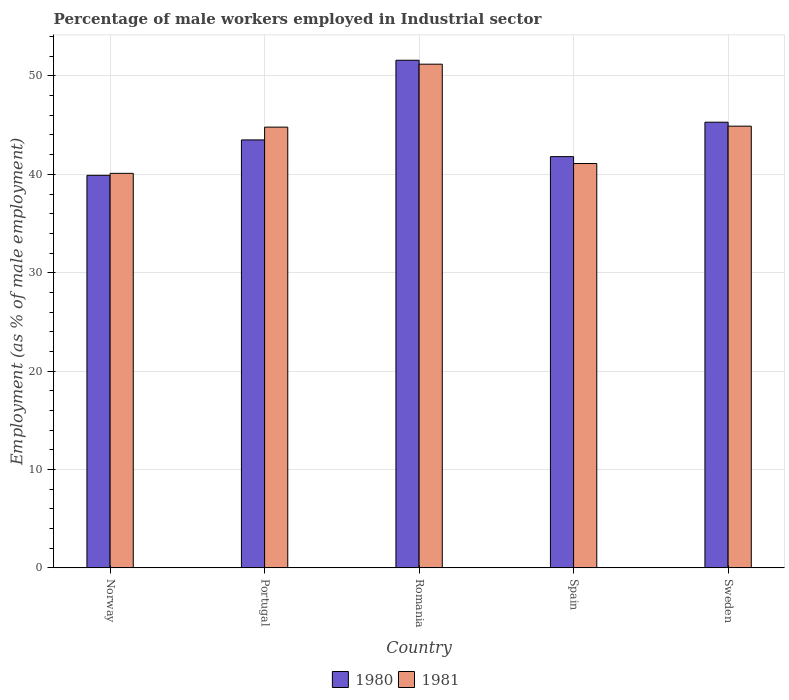How many different coloured bars are there?
Provide a succinct answer. 2. How many groups of bars are there?
Make the answer very short. 5. Are the number of bars on each tick of the X-axis equal?
Your answer should be compact. Yes. How many bars are there on the 2nd tick from the left?
Provide a short and direct response. 2. How many bars are there on the 3rd tick from the right?
Offer a very short reply. 2. What is the label of the 3rd group of bars from the left?
Provide a short and direct response. Romania. What is the percentage of male workers employed in Industrial sector in 1981 in Sweden?
Your response must be concise. 44.9. Across all countries, what is the maximum percentage of male workers employed in Industrial sector in 1980?
Make the answer very short. 51.6. Across all countries, what is the minimum percentage of male workers employed in Industrial sector in 1980?
Keep it short and to the point. 39.9. In which country was the percentage of male workers employed in Industrial sector in 1981 maximum?
Provide a succinct answer. Romania. What is the total percentage of male workers employed in Industrial sector in 1980 in the graph?
Give a very brief answer. 222.1. What is the difference between the percentage of male workers employed in Industrial sector in 1980 in Norway and that in Portugal?
Your answer should be very brief. -3.6. What is the difference between the percentage of male workers employed in Industrial sector in 1981 in Portugal and the percentage of male workers employed in Industrial sector in 1980 in Spain?
Keep it short and to the point. 3. What is the average percentage of male workers employed in Industrial sector in 1981 per country?
Your answer should be very brief. 44.42. What is the difference between the percentage of male workers employed in Industrial sector of/in 1981 and percentage of male workers employed in Industrial sector of/in 1980 in Romania?
Ensure brevity in your answer.  -0.4. What is the ratio of the percentage of male workers employed in Industrial sector in 1981 in Portugal to that in Spain?
Provide a succinct answer. 1.09. Is the percentage of male workers employed in Industrial sector in 1980 in Portugal less than that in Romania?
Your answer should be very brief. Yes. Is the difference between the percentage of male workers employed in Industrial sector in 1981 in Norway and Sweden greater than the difference between the percentage of male workers employed in Industrial sector in 1980 in Norway and Sweden?
Your answer should be very brief. Yes. What is the difference between the highest and the second highest percentage of male workers employed in Industrial sector in 1980?
Offer a very short reply. -8.1. What is the difference between the highest and the lowest percentage of male workers employed in Industrial sector in 1981?
Offer a terse response. 11.1. What does the 1st bar from the left in Portugal represents?
Your response must be concise. 1980. How many bars are there?
Your response must be concise. 10. Does the graph contain any zero values?
Provide a succinct answer. No. Does the graph contain grids?
Make the answer very short. Yes. Where does the legend appear in the graph?
Your response must be concise. Bottom center. How many legend labels are there?
Provide a short and direct response. 2. How are the legend labels stacked?
Provide a succinct answer. Horizontal. What is the title of the graph?
Make the answer very short. Percentage of male workers employed in Industrial sector. What is the label or title of the Y-axis?
Provide a succinct answer. Employment (as % of male employment). What is the Employment (as % of male employment) of 1980 in Norway?
Keep it short and to the point. 39.9. What is the Employment (as % of male employment) in 1981 in Norway?
Provide a short and direct response. 40.1. What is the Employment (as % of male employment) of 1980 in Portugal?
Your answer should be compact. 43.5. What is the Employment (as % of male employment) in 1981 in Portugal?
Make the answer very short. 44.8. What is the Employment (as % of male employment) in 1980 in Romania?
Offer a very short reply. 51.6. What is the Employment (as % of male employment) of 1981 in Romania?
Make the answer very short. 51.2. What is the Employment (as % of male employment) of 1980 in Spain?
Keep it short and to the point. 41.8. What is the Employment (as % of male employment) in 1981 in Spain?
Your response must be concise. 41.1. What is the Employment (as % of male employment) of 1980 in Sweden?
Your response must be concise. 45.3. What is the Employment (as % of male employment) in 1981 in Sweden?
Offer a very short reply. 44.9. Across all countries, what is the maximum Employment (as % of male employment) in 1980?
Provide a short and direct response. 51.6. Across all countries, what is the maximum Employment (as % of male employment) in 1981?
Give a very brief answer. 51.2. Across all countries, what is the minimum Employment (as % of male employment) of 1980?
Give a very brief answer. 39.9. Across all countries, what is the minimum Employment (as % of male employment) in 1981?
Offer a terse response. 40.1. What is the total Employment (as % of male employment) in 1980 in the graph?
Your answer should be very brief. 222.1. What is the total Employment (as % of male employment) in 1981 in the graph?
Offer a terse response. 222.1. What is the difference between the Employment (as % of male employment) in 1980 in Norway and that in Spain?
Provide a short and direct response. -1.9. What is the difference between the Employment (as % of male employment) of 1980 in Norway and that in Sweden?
Provide a short and direct response. -5.4. What is the difference between the Employment (as % of male employment) in 1980 in Portugal and that in Romania?
Ensure brevity in your answer.  -8.1. What is the difference between the Employment (as % of male employment) in 1981 in Portugal and that in Romania?
Your answer should be compact. -6.4. What is the difference between the Employment (as % of male employment) of 1980 in Portugal and that in Spain?
Keep it short and to the point. 1.7. What is the difference between the Employment (as % of male employment) in 1981 in Portugal and that in Spain?
Your answer should be compact. 3.7. What is the difference between the Employment (as % of male employment) in 1980 in Portugal and that in Sweden?
Offer a very short reply. -1.8. What is the difference between the Employment (as % of male employment) of 1981 in Portugal and that in Sweden?
Make the answer very short. -0.1. What is the difference between the Employment (as % of male employment) of 1980 in Romania and that in Spain?
Give a very brief answer. 9.8. What is the difference between the Employment (as % of male employment) of 1981 in Romania and that in Sweden?
Ensure brevity in your answer.  6.3. What is the difference between the Employment (as % of male employment) in 1981 in Spain and that in Sweden?
Give a very brief answer. -3.8. What is the difference between the Employment (as % of male employment) in 1980 in Norway and the Employment (as % of male employment) in 1981 in Portugal?
Provide a succinct answer. -4.9. What is the difference between the Employment (as % of male employment) of 1980 in Norway and the Employment (as % of male employment) of 1981 in Spain?
Make the answer very short. -1.2. What is the difference between the Employment (as % of male employment) in 1980 in Norway and the Employment (as % of male employment) in 1981 in Sweden?
Give a very brief answer. -5. What is the difference between the Employment (as % of male employment) of 1980 in Portugal and the Employment (as % of male employment) of 1981 in Romania?
Provide a short and direct response. -7.7. What is the difference between the Employment (as % of male employment) of 1980 in Romania and the Employment (as % of male employment) of 1981 in Spain?
Provide a short and direct response. 10.5. What is the average Employment (as % of male employment) of 1980 per country?
Offer a terse response. 44.42. What is the average Employment (as % of male employment) in 1981 per country?
Offer a very short reply. 44.42. What is the difference between the Employment (as % of male employment) in 1980 and Employment (as % of male employment) in 1981 in Norway?
Ensure brevity in your answer.  -0.2. What is the difference between the Employment (as % of male employment) of 1980 and Employment (as % of male employment) of 1981 in Spain?
Provide a short and direct response. 0.7. What is the ratio of the Employment (as % of male employment) of 1980 in Norway to that in Portugal?
Keep it short and to the point. 0.92. What is the ratio of the Employment (as % of male employment) in 1981 in Norway to that in Portugal?
Offer a very short reply. 0.9. What is the ratio of the Employment (as % of male employment) in 1980 in Norway to that in Romania?
Your answer should be compact. 0.77. What is the ratio of the Employment (as % of male employment) of 1981 in Norway to that in Romania?
Your response must be concise. 0.78. What is the ratio of the Employment (as % of male employment) of 1980 in Norway to that in Spain?
Provide a succinct answer. 0.95. What is the ratio of the Employment (as % of male employment) of 1981 in Norway to that in Spain?
Give a very brief answer. 0.98. What is the ratio of the Employment (as % of male employment) in 1980 in Norway to that in Sweden?
Keep it short and to the point. 0.88. What is the ratio of the Employment (as % of male employment) of 1981 in Norway to that in Sweden?
Ensure brevity in your answer.  0.89. What is the ratio of the Employment (as % of male employment) of 1980 in Portugal to that in Romania?
Keep it short and to the point. 0.84. What is the ratio of the Employment (as % of male employment) of 1980 in Portugal to that in Spain?
Ensure brevity in your answer.  1.04. What is the ratio of the Employment (as % of male employment) in 1981 in Portugal to that in Spain?
Offer a terse response. 1.09. What is the ratio of the Employment (as % of male employment) in 1980 in Portugal to that in Sweden?
Keep it short and to the point. 0.96. What is the ratio of the Employment (as % of male employment) in 1980 in Romania to that in Spain?
Provide a succinct answer. 1.23. What is the ratio of the Employment (as % of male employment) of 1981 in Romania to that in Spain?
Provide a short and direct response. 1.25. What is the ratio of the Employment (as % of male employment) in 1980 in Romania to that in Sweden?
Make the answer very short. 1.14. What is the ratio of the Employment (as % of male employment) of 1981 in Romania to that in Sweden?
Make the answer very short. 1.14. What is the ratio of the Employment (as % of male employment) of 1980 in Spain to that in Sweden?
Your response must be concise. 0.92. What is the ratio of the Employment (as % of male employment) in 1981 in Spain to that in Sweden?
Provide a succinct answer. 0.92. What is the difference between the highest and the second highest Employment (as % of male employment) in 1981?
Make the answer very short. 6.3. 